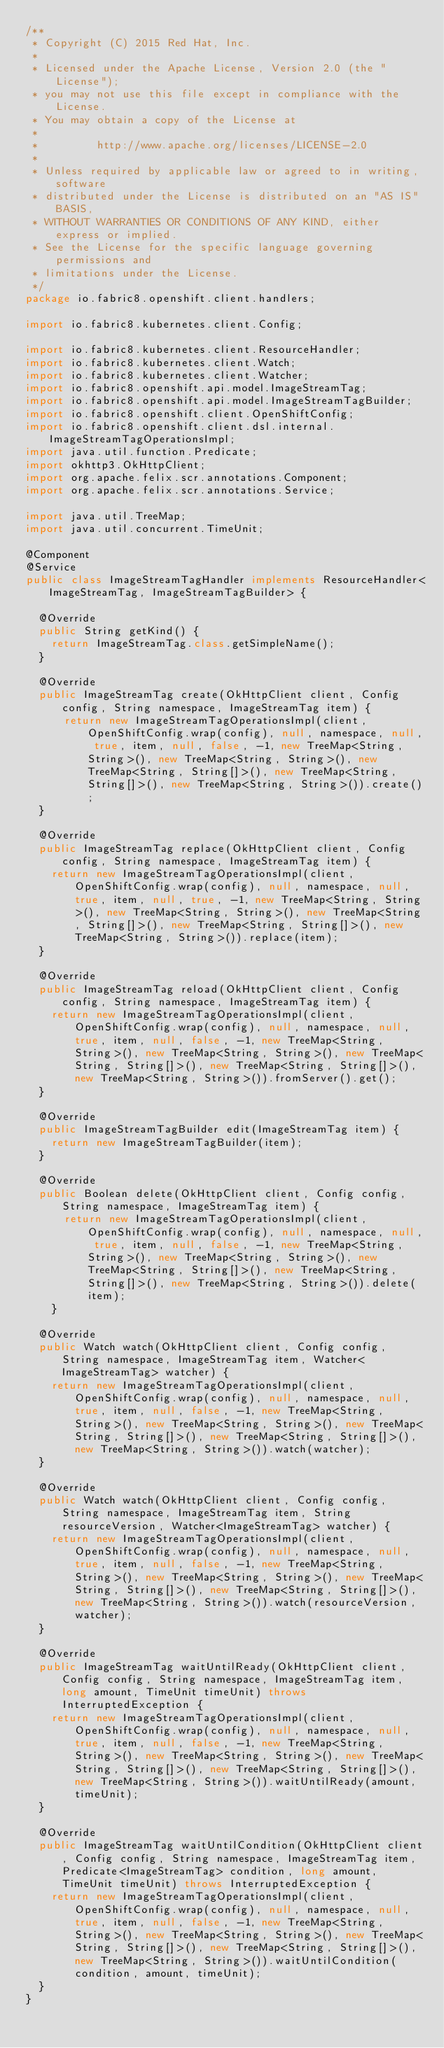<code> <loc_0><loc_0><loc_500><loc_500><_Java_>/**
 * Copyright (C) 2015 Red Hat, Inc.
 *
 * Licensed under the Apache License, Version 2.0 (the "License");
 * you may not use this file except in compliance with the License.
 * You may obtain a copy of the License at
 *
 *         http://www.apache.org/licenses/LICENSE-2.0
 *
 * Unless required by applicable law or agreed to in writing, software
 * distributed under the License is distributed on an "AS IS" BASIS,
 * WITHOUT WARRANTIES OR CONDITIONS OF ANY KIND, either express or implied.
 * See the License for the specific language governing permissions and
 * limitations under the License.
 */
package io.fabric8.openshift.client.handlers;

import io.fabric8.kubernetes.client.Config;

import io.fabric8.kubernetes.client.ResourceHandler;
import io.fabric8.kubernetes.client.Watch;
import io.fabric8.kubernetes.client.Watcher;
import io.fabric8.openshift.api.model.ImageStreamTag;
import io.fabric8.openshift.api.model.ImageStreamTagBuilder;
import io.fabric8.openshift.client.OpenShiftConfig;
import io.fabric8.openshift.client.dsl.internal.ImageStreamTagOperationsImpl;
import java.util.function.Predicate;
import okhttp3.OkHttpClient;
import org.apache.felix.scr.annotations.Component;
import org.apache.felix.scr.annotations.Service;

import java.util.TreeMap;
import java.util.concurrent.TimeUnit;

@Component
@Service
public class ImageStreamTagHandler implements ResourceHandler<ImageStreamTag, ImageStreamTagBuilder> {

  @Override
  public String getKind() {
    return ImageStreamTag.class.getSimpleName();
  }

  @Override
  public ImageStreamTag create(OkHttpClient client, Config config, String namespace, ImageStreamTag item) {
      return new ImageStreamTagOperationsImpl(client, OpenShiftConfig.wrap(config), null, namespace, null, true, item, null, false, -1, new TreeMap<String, String>(), new TreeMap<String, String>(), new TreeMap<String, String[]>(), new TreeMap<String, String[]>(), new TreeMap<String, String>()).create();
  }

  @Override
  public ImageStreamTag replace(OkHttpClient client, Config config, String namespace, ImageStreamTag item) {
    return new ImageStreamTagOperationsImpl(client, OpenShiftConfig.wrap(config), null, namespace, null, true, item, null, true, -1, new TreeMap<String, String>(), new TreeMap<String, String>(), new TreeMap<String, String[]>(), new TreeMap<String, String[]>(), new TreeMap<String, String>()).replace(item);
  }

  @Override
  public ImageStreamTag reload(OkHttpClient client, Config config, String namespace, ImageStreamTag item) {
    return new ImageStreamTagOperationsImpl(client, OpenShiftConfig.wrap(config), null, namespace, null, true, item, null, false, -1, new TreeMap<String, String>(), new TreeMap<String, String>(), new TreeMap<String, String[]>(), new TreeMap<String, String[]>(), new TreeMap<String, String>()).fromServer().get();
  }

  @Override
  public ImageStreamTagBuilder edit(ImageStreamTag item) {
    return new ImageStreamTagBuilder(item);
  }

  @Override
  public Boolean delete(OkHttpClient client, Config config, String namespace, ImageStreamTag item) {
      return new ImageStreamTagOperationsImpl(client, OpenShiftConfig.wrap(config), null, namespace, null, true, item, null, false, -1, new TreeMap<String, String>(), new TreeMap<String, String>(), new TreeMap<String, String[]>(), new TreeMap<String, String[]>(), new TreeMap<String, String>()).delete(item);
    }

  @Override
  public Watch watch(OkHttpClient client, Config config, String namespace, ImageStreamTag item, Watcher<ImageStreamTag> watcher) {
    return new ImageStreamTagOperationsImpl(client, OpenShiftConfig.wrap(config), null, namespace, null, true, item, null, false, -1, new TreeMap<String, String>(), new TreeMap<String, String>(), new TreeMap<String, String[]>(), new TreeMap<String, String[]>(), new TreeMap<String, String>()).watch(watcher);
  }

  @Override
  public Watch watch(OkHttpClient client, Config config, String namespace, ImageStreamTag item, String resourceVersion, Watcher<ImageStreamTag> watcher) {
    return new ImageStreamTagOperationsImpl(client, OpenShiftConfig.wrap(config), null, namespace, null, true, item, null, false, -1, new TreeMap<String, String>(), new TreeMap<String, String>(), new TreeMap<String, String[]>(), new TreeMap<String, String[]>(), new TreeMap<String, String>()).watch(resourceVersion, watcher);
  }

  @Override
  public ImageStreamTag waitUntilReady(OkHttpClient client, Config config, String namespace, ImageStreamTag item, long amount, TimeUnit timeUnit) throws InterruptedException {
    return new ImageStreamTagOperationsImpl(client, OpenShiftConfig.wrap(config), null, namespace, null, true, item, null, false, -1, new TreeMap<String, String>(), new TreeMap<String, String>(), new TreeMap<String, String[]>(), new TreeMap<String, String[]>(), new TreeMap<String, String>()).waitUntilReady(amount, timeUnit);
  }

  @Override
  public ImageStreamTag waitUntilCondition(OkHttpClient client, Config config, String namespace, ImageStreamTag item, Predicate<ImageStreamTag> condition, long amount, TimeUnit timeUnit) throws InterruptedException {
    return new ImageStreamTagOperationsImpl(client, OpenShiftConfig.wrap(config), null, namespace, null, true, item, null, false, -1, new TreeMap<String, String>(), new TreeMap<String, String>(), new TreeMap<String, String[]>(), new TreeMap<String, String[]>(), new TreeMap<String, String>()).waitUntilCondition(condition, amount, timeUnit);
  }
}
</code> 